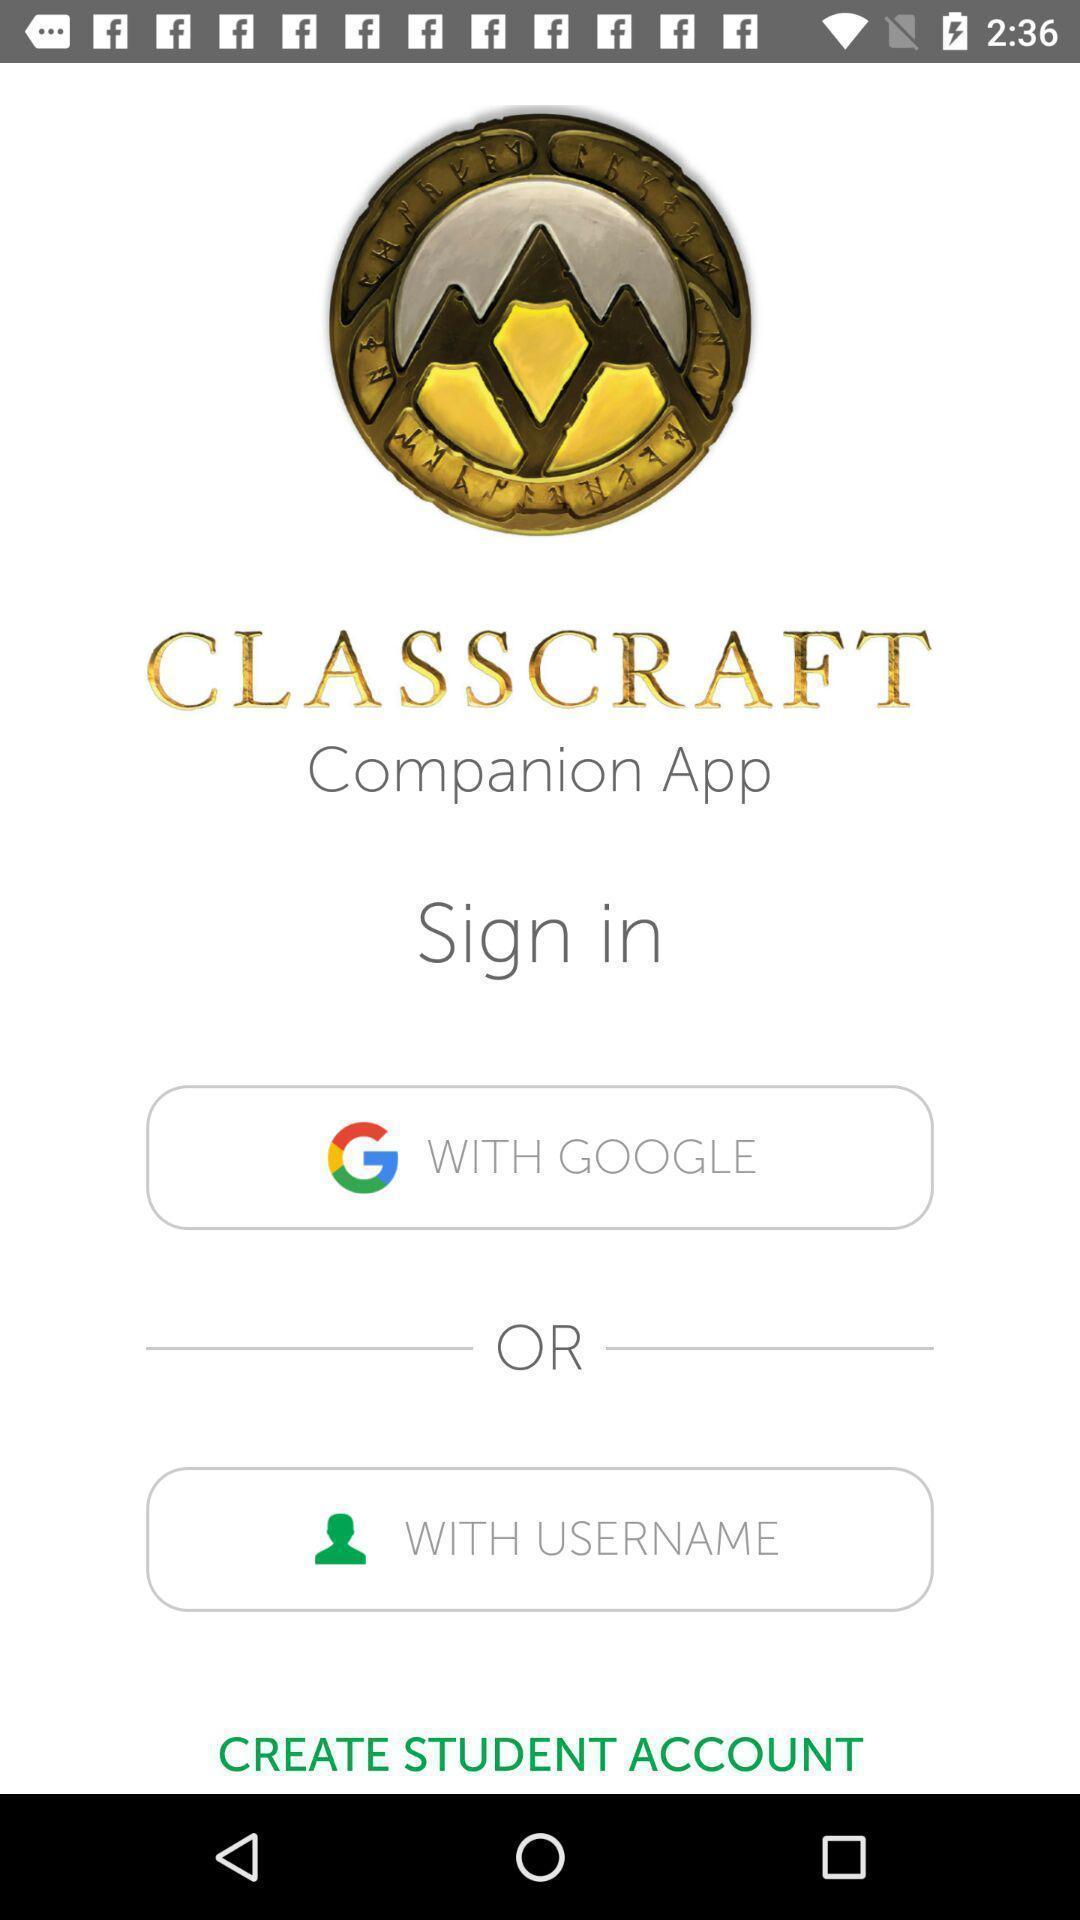Please provide a description for this image. Sign-in page. 